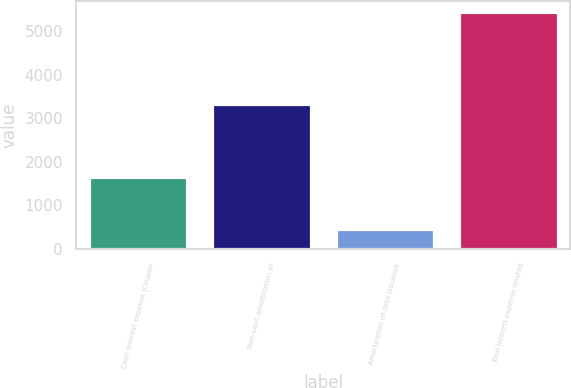<chart> <loc_0><loc_0><loc_500><loc_500><bar_chart><fcel>Cash interest expense (coupon<fcel>Non-cash amortization of<fcel>Amortization of debt issuance<fcel>Total interest expense related<nl><fcel>1641<fcel>3336<fcel>449<fcel>5426<nl></chart> 